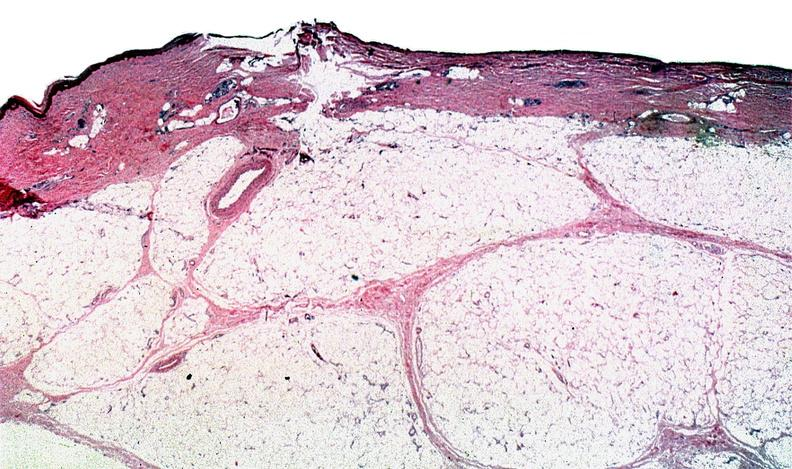where is this?
Answer the question using a single word or phrase. Skin 